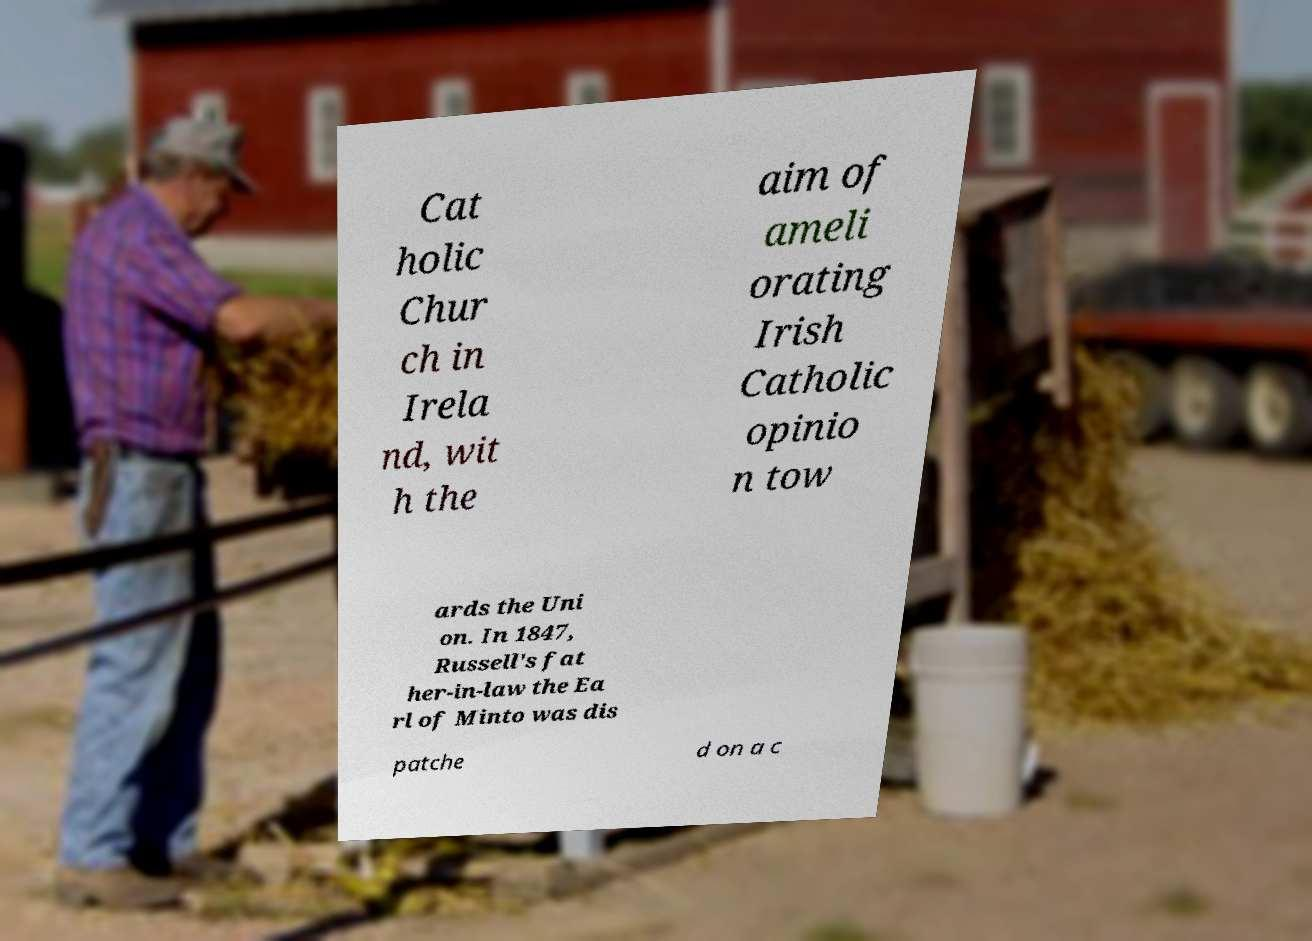I need the written content from this picture converted into text. Can you do that? Cat holic Chur ch in Irela nd, wit h the aim of ameli orating Irish Catholic opinio n tow ards the Uni on. In 1847, Russell's fat her-in-law the Ea rl of Minto was dis patche d on a c 